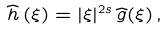<formula> <loc_0><loc_0><loc_500><loc_500>\widehat { h } \, ( \xi ) = | \xi | ^ { 2 s } \, \widehat { g } ( \xi ) \, ,</formula> 